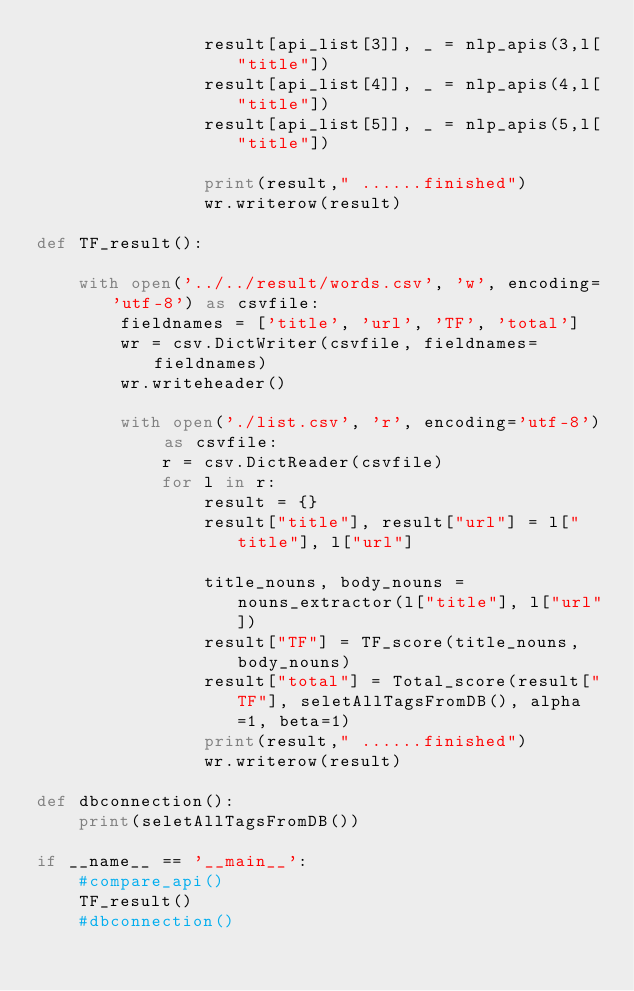Convert code to text. <code><loc_0><loc_0><loc_500><loc_500><_Python_>                result[api_list[3]], _ = nlp_apis(3,l["title"])
                result[api_list[4]], _ = nlp_apis(4,l["title"])
                result[api_list[5]], _ = nlp_apis(5,l["title"])

                print(result," ......finished")
                wr.writerow(result)

def TF_result():

    with open('../../result/words.csv', 'w', encoding='utf-8') as csvfile:
        fieldnames = ['title', 'url', 'TF', 'total']
        wr = csv.DictWriter(csvfile, fieldnames=fieldnames)
        wr.writeheader()

        with open('./list.csv', 'r', encoding='utf-8') as csvfile:
            r = csv.DictReader(csvfile)
            for l in r:
                result = {}
                result["title"], result["url"] = l["title"], l["url"]
                
                title_nouns, body_nouns = nouns_extractor(l["title"], l["url"])
                result["TF"] = TF_score(title_nouns, body_nouns)
                result["total"] = Total_score(result["TF"], seletAllTagsFromDB(), alpha=1, beta=1)
                print(result," ......finished")
                wr.writerow(result)

def dbconnection():
    print(seletAllTagsFromDB())

if __name__ == '__main__':
    #compare_api()
    TF_result()
    #dbconnection()</code> 